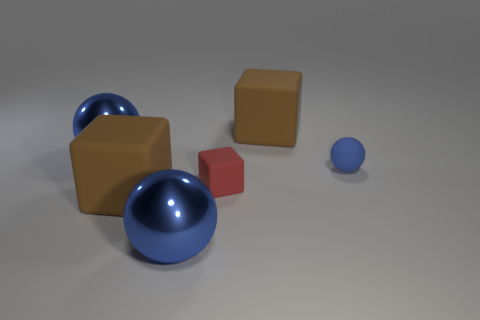How many small red things have the same material as the small cube?
Your response must be concise. 0. There is a red cube; is it the same size as the matte ball that is behind the tiny red thing?
Provide a succinct answer. Yes. There is a shiny object that is behind the blue object that is in front of the blue matte ball on the right side of the small red matte block; what is its size?
Offer a terse response. Large. Is the number of small blue balls that are in front of the matte sphere greater than the number of red matte objects that are on the right side of the tiny red rubber object?
Keep it short and to the point. No. There is a blue object behind the tiny blue ball; what number of big things are in front of it?
Your response must be concise. 2. Is there a tiny matte object of the same color as the small cube?
Your answer should be very brief. No. Do the matte sphere and the red matte block have the same size?
Provide a succinct answer. Yes. Do the tiny cube and the tiny ball have the same color?
Provide a short and direct response. No. There is a large brown object that is on the right side of the large blue ball in front of the red matte object; what is it made of?
Provide a short and direct response. Rubber. Do the blue thing behind the rubber sphere and the small blue rubber thing have the same size?
Your answer should be very brief. No. 